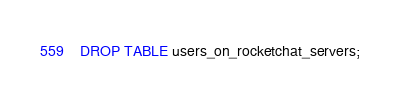<code> <loc_0><loc_0><loc_500><loc_500><_SQL_>DROP TABLE users_on_rocketchat_servers;
</code> 